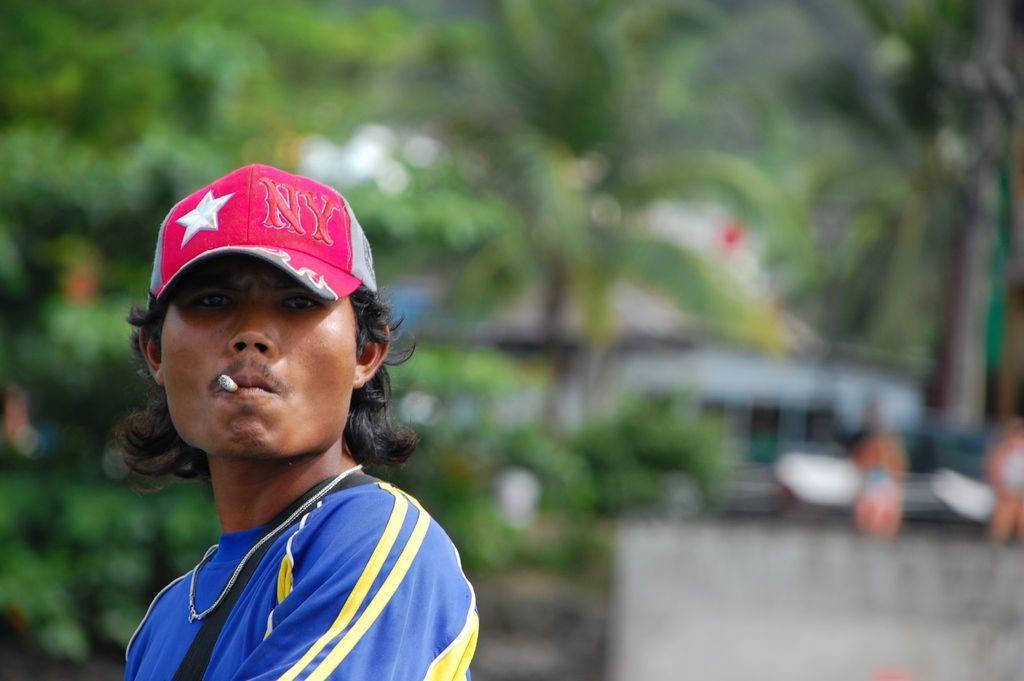Describe this image in one or two sentences. In the picture I can see a man is standing. The man is wearing a cap and holding a cigarette in the mouth. In the background I can see trees and some other objects. The background of the image is blurred. 